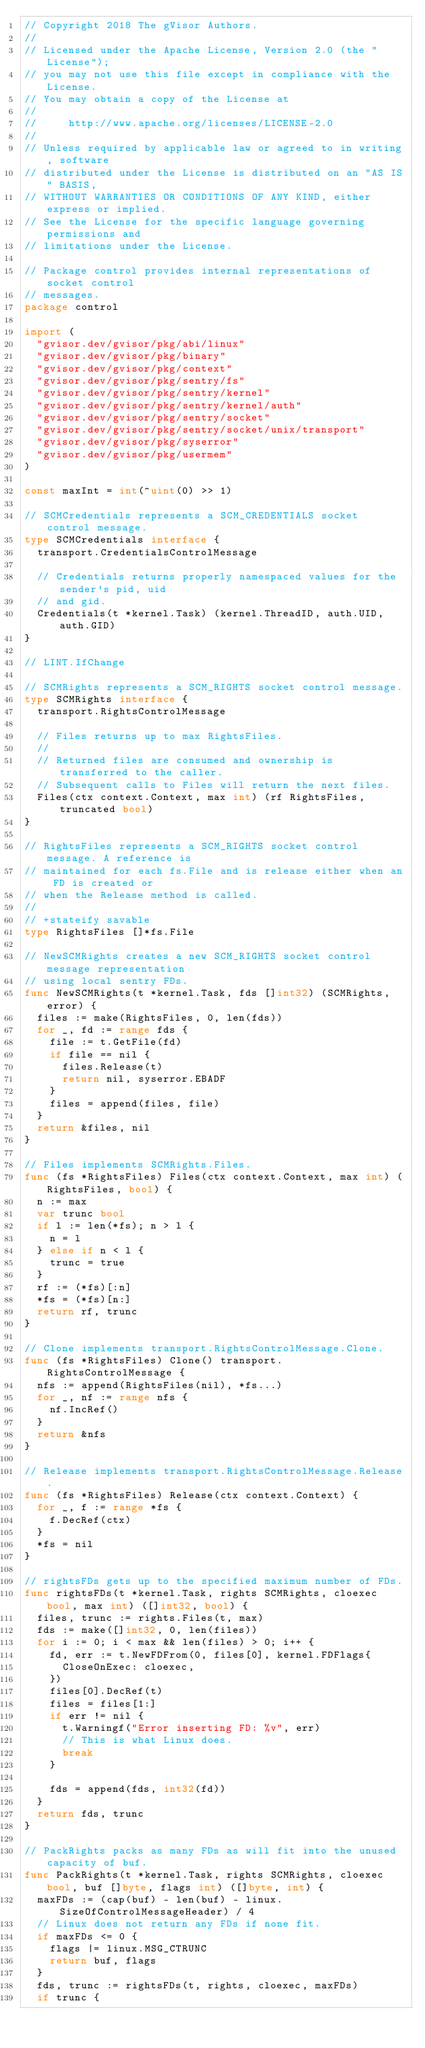Convert code to text. <code><loc_0><loc_0><loc_500><loc_500><_Go_>// Copyright 2018 The gVisor Authors.
//
// Licensed under the Apache License, Version 2.0 (the "License");
// you may not use this file except in compliance with the License.
// You may obtain a copy of the License at
//
//     http://www.apache.org/licenses/LICENSE-2.0
//
// Unless required by applicable law or agreed to in writing, software
// distributed under the License is distributed on an "AS IS" BASIS,
// WITHOUT WARRANTIES OR CONDITIONS OF ANY KIND, either express or implied.
// See the License for the specific language governing permissions and
// limitations under the License.

// Package control provides internal representations of socket control
// messages.
package control

import (
	"gvisor.dev/gvisor/pkg/abi/linux"
	"gvisor.dev/gvisor/pkg/binary"
	"gvisor.dev/gvisor/pkg/context"
	"gvisor.dev/gvisor/pkg/sentry/fs"
	"gvisor.dev/gvisor/pkg/sentry/kernel"
	"gvisor.dev/gvisor/pkg/sentry/kernel/auth"
	"gvisor.dev/gvisor/pkg/sentry/socket"
	"gvisor.dev/gvisor/pkg/sentry/socket/unix/transport"
	"gvisor.dev/gvisor/pkg/syserror"
	"gvisor.dev/gvisor/pkg/usermem"
)

const maxInt = int(^uint(0) >> 1)

// SCMCredentials represents a SCM_CREDENTIALS socket control message.
type SCMCredentials interface {
	transport.CredentialsControlMessage

	// Credentials returns properly namespaced values for the sender's pid, uid
	// and gid.
	Credentials(t *kernel.Task) (kernel.ThreadID, auth.UID, auth.GID)
}

// LINT.IfChange

// SCMRights represents a SCM_RIGHTS socket control message.
type SCMRights interface {
	transport.RightsControlMessage

	// Files returns up to max RightsFiles.
	//
	// Returned files are consumed and ownership is transferred to the caller.
	// Subsequent calls to Files will return the next files.
	Files(ctx context.Context, max int) (rf RightsFiles, truncated bool)
}

// RightsFiles represents a SCM_RIGHTS socket control message. A reference is
// maintained for each fs.File and is release either when an FD is created or
// when the Release method is called.
//
// +stateify savable
type RightsFiles []*fs.File

// NewSCMRights creates a new SCM_RIGHTS socket control message representation
// using local sentry FDs.
func NewSCMRights(t *kernel.Task, fds []int32) (SCMRights, error) {
	files := make(RightsFiles, 0, len(fds))
	for _, fd := range fds {
		file := t.GetFile(fd)
		if file == nil {
			files.Release(t)
			return nil, syserror.EBADF
		}
		files = append(files, file)
	}
	return &files, nil
}

// Files implements SCMRights.Files.
func (fs *RightsFiles) Files(ctx context.Context, max int) (RightsFiles, bool) {
	n := max
	var trunc bool
	if l := len(*fs); n > l {
		n = l
	} else if n < l {
		trunc = true
	}
	rf := (*fs)[:n]
	*fs = (*fs)[n:]
	return rf, trunc
}

// Clone implements transport.RightsControlMessage.Clone.
func (fs *RightsFiles) Clone() transport.RightsControlMessage {
	nfs := append(RightsFiles(nil), *fs...)
	for _, nf := range nfs {
		nf.IncRef()
	}
	return &nfs
}

// Release implements transport.RightsControlMessage.Release.
func (fs *RightsFiles) Release(ctx context.Context) {
	for _, f := range *fs {
		f.DecRef(ctx)
	}
	*fs = nil
}

// rightsFDs gets up to the specified maximum number of FDs.
func rightsFDs(t *kernel.Task, rights SCMRights, cloexec bool, max int) ([]int32, bool) {
	files, trunc := rights.Files(t, max)
	fds := make([]int32, 0, len(files))
	for i := 0; i < max && len(files) > 0; i++ {
		fd, err := t.NewFDFrom(0, files[0], kernel.FDFlags{
			CloseOnExec: cloexec,
		})
		files[0].DecRef(t)
		files = files[1:]
		if err != nil {
			t.Warningf("Error inserting FD: %v", err)
			// This is what Linux does.
			break
		}

		fds = append(fds, int32(fd))
	}
	return fds, trunc
}

// PackRights packs as many FDs as will fit into the unused capacity of buf.
func PackRights(t *kernel.Task, rights SCMRights, cloexec bool, buf []byte, flags int) ([]byte, int) {
	maxFDs := (cap(buf) - len(buf) - linux.SizeOfControlMessageHeader) / 4
	// Linux does not return any FDs if none fit.
	if maxFDs <= 0 {
		flags |= linux.MSG_CTRUNC
		return buf, flags
	}
	fds, trunc := rightsFDs(t, rights, cloexec, maxFDs)
	if trunc {</code> 